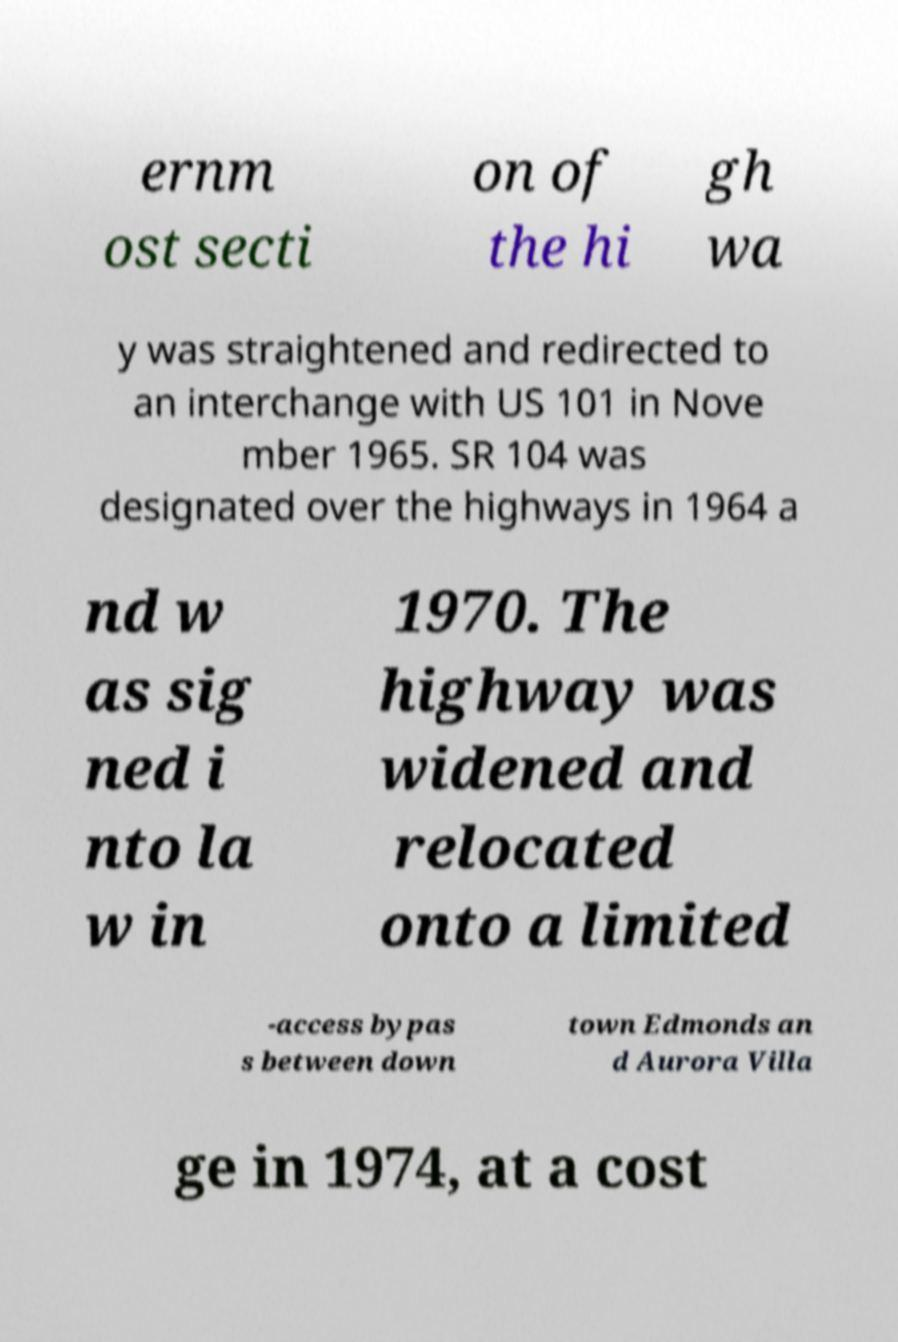Can you accurately transcribe the text from the provided image for me? ernm ost secti on of the hi gh wa y was straightened and redirected to an interchange with US 101 in Nove mber 1965. SR 104 was designated over the highways in 1964 a nd w as sig ned i nto la w in 1970. The highway was widened and relocated onto a limited -access bypas s between down town Edmonds an d Aurora Villa ge in 1974, at a cost 